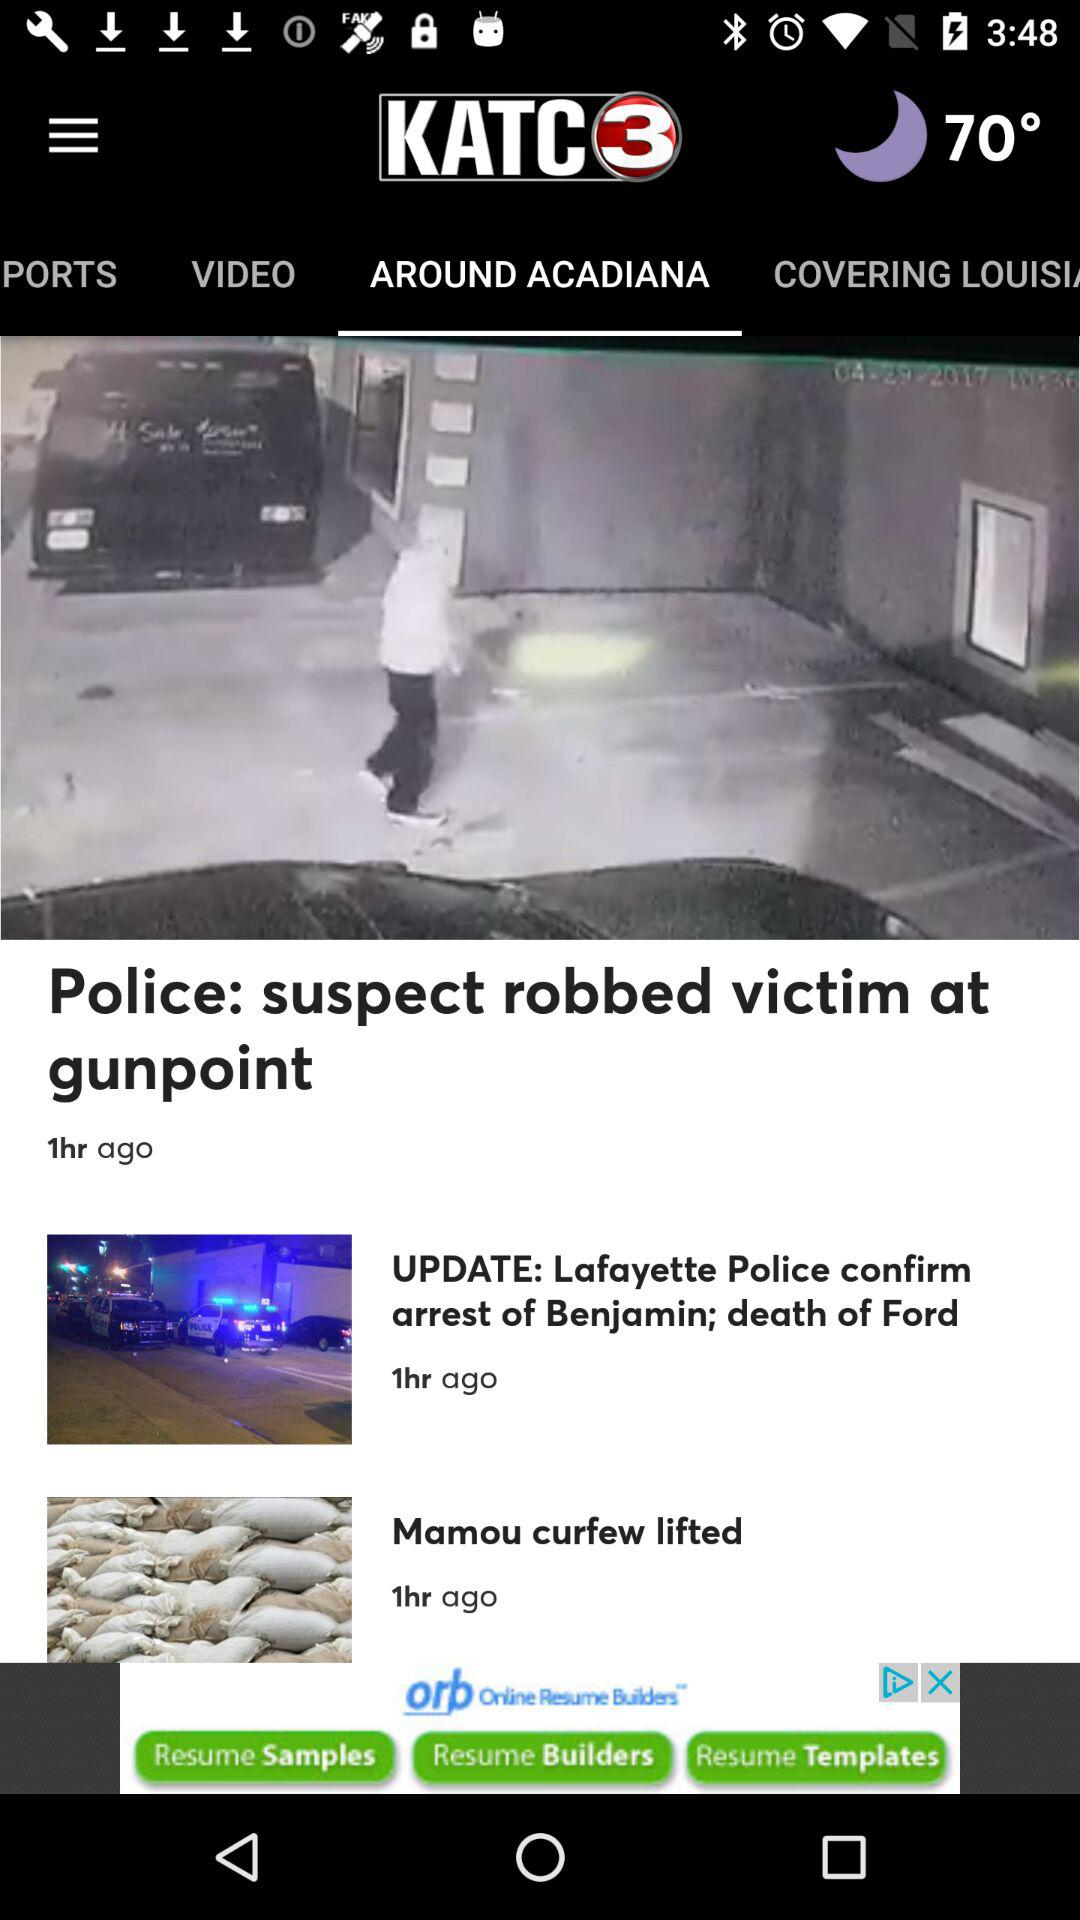What is the temperature? The temperature is 70°. 